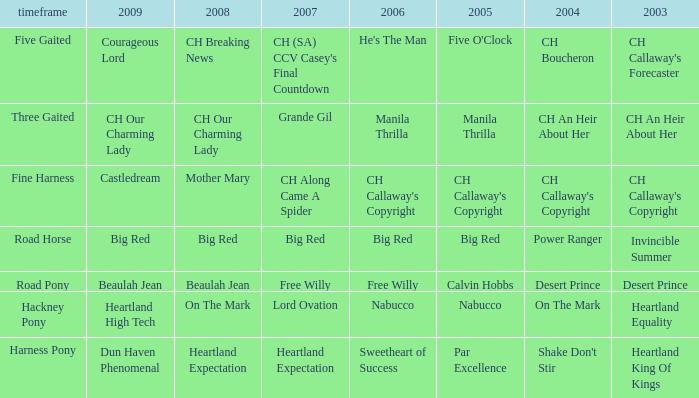What is the 2008 for the 2009 ch our charming lady? CH Our Charming Lady. 